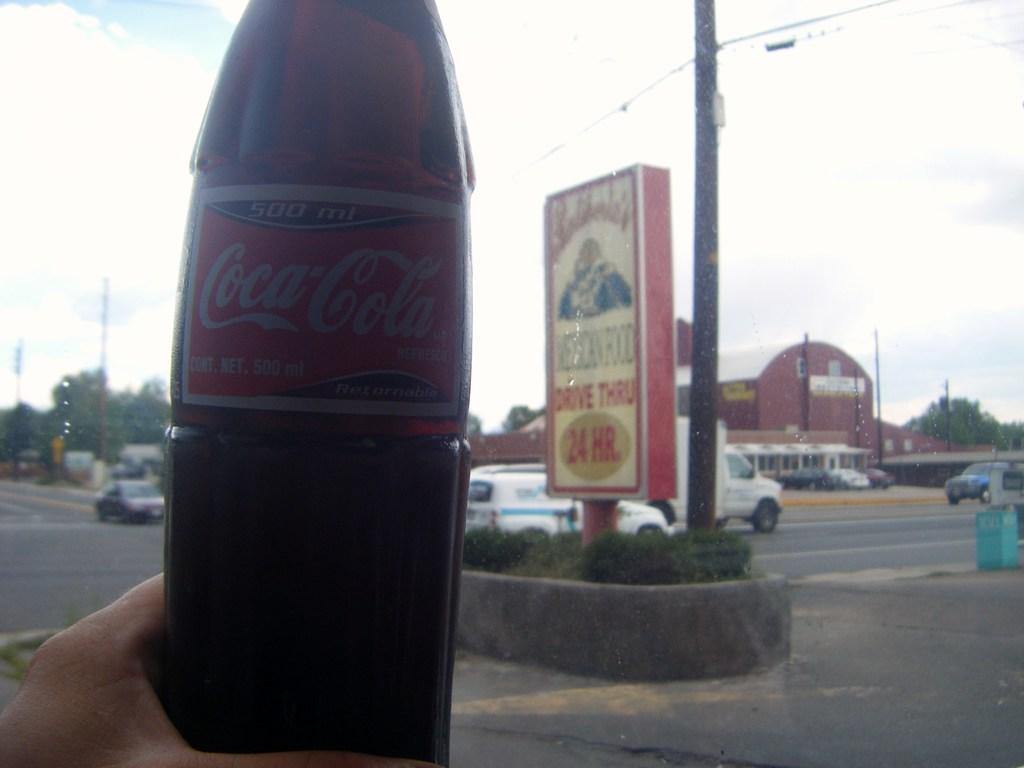<image>
Present a compact description of the photo's key features. A bottle of Coca-Cola is being held up near a drive-thru sign. 